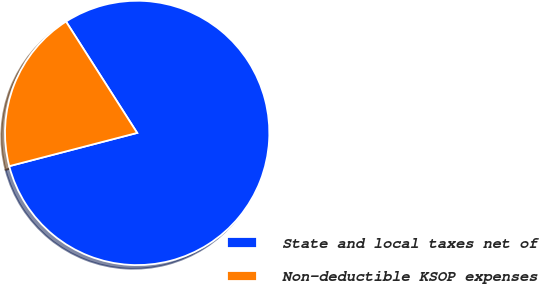Convert chart to OTSL. <chart><loc_0><loc_0><loc_500><loc_500><pie_chart><fcel>State and local taxes net of<fcel>Non-deductible KSOP expenses<nl><fcel>80.0%<fcel>20.0%<nl></chart> 